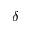Convert formula to latex. <formula><loc_0><loc_0><loc_500><loc_500>\delta</formula> 